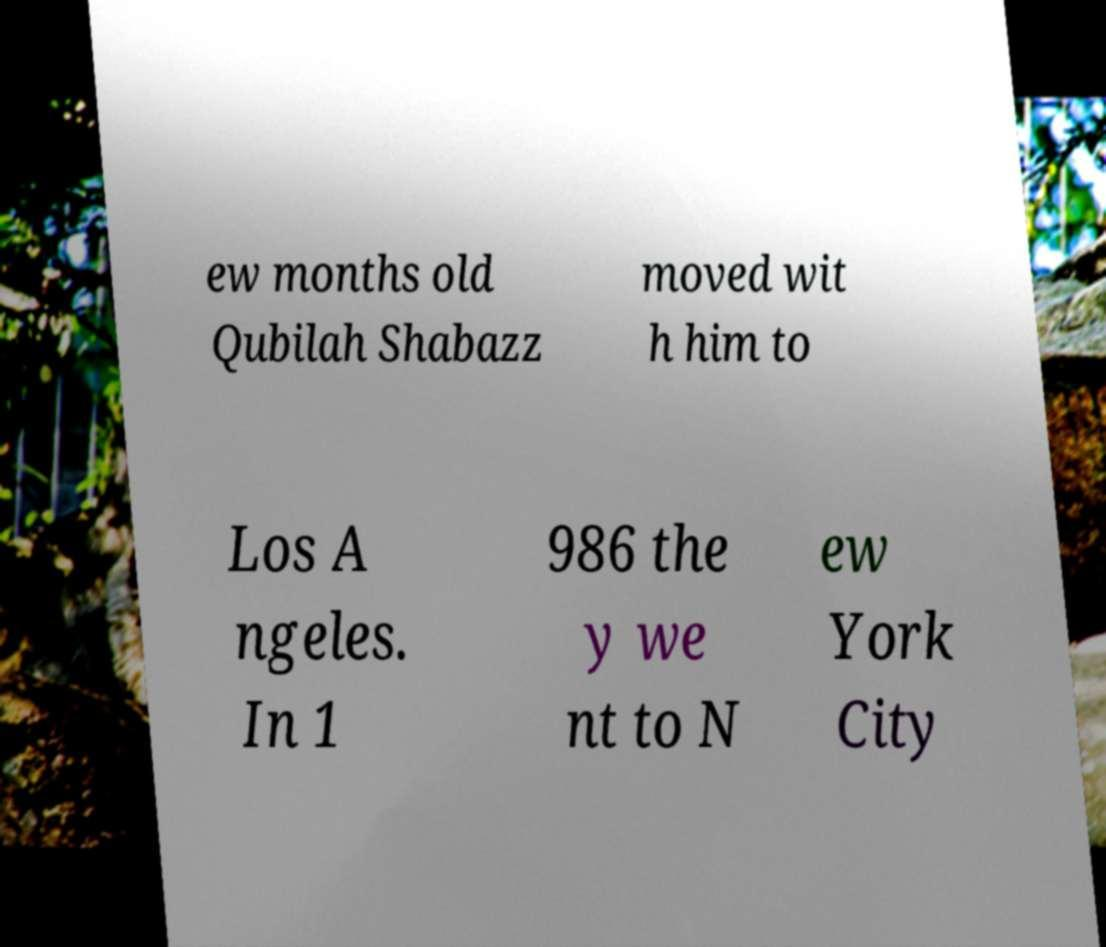Can you accurately transcribe the text from the provided image for me? ew months old Qubilah Shabazz moved wit h him to Los A ngeles. In 1 986 the y we nt to N ew York City 